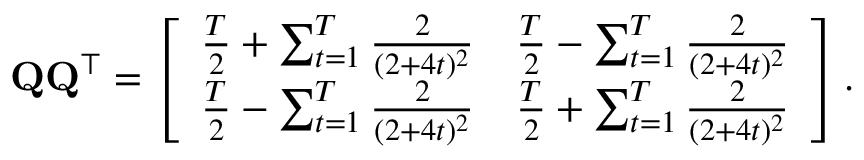Convert formula to latex. <formula><loc_0><loc_0><loc_500><loc_500>Q Q ^ { \top } = \left [ \begin{array} { l l } { \frac { T } { 2 } + \sum _ { t = 1 } ^ { T } \frac { 2 } { ( 2 + 4 t ) ^ { 2 } } } & { \frac { T } { 2 } - \sum _ { t = 1 } ^ { T } \frac { 2 } { ( 2 + 4 t ) ^ { 2 } } } \\ { \frac { T } { 2 } - \sum _ { t = 1 } ^ { T } \frac { 2 } { ( 2 + 4 t ) ^ { 2 } } } & { \frac { T } { 2 } + \sum _ { t = 1 } ^ { T } \frac { 2 } { ( 2 + 4 t ) ^ { 2 } } } \end{array} \right ] .</formula> 